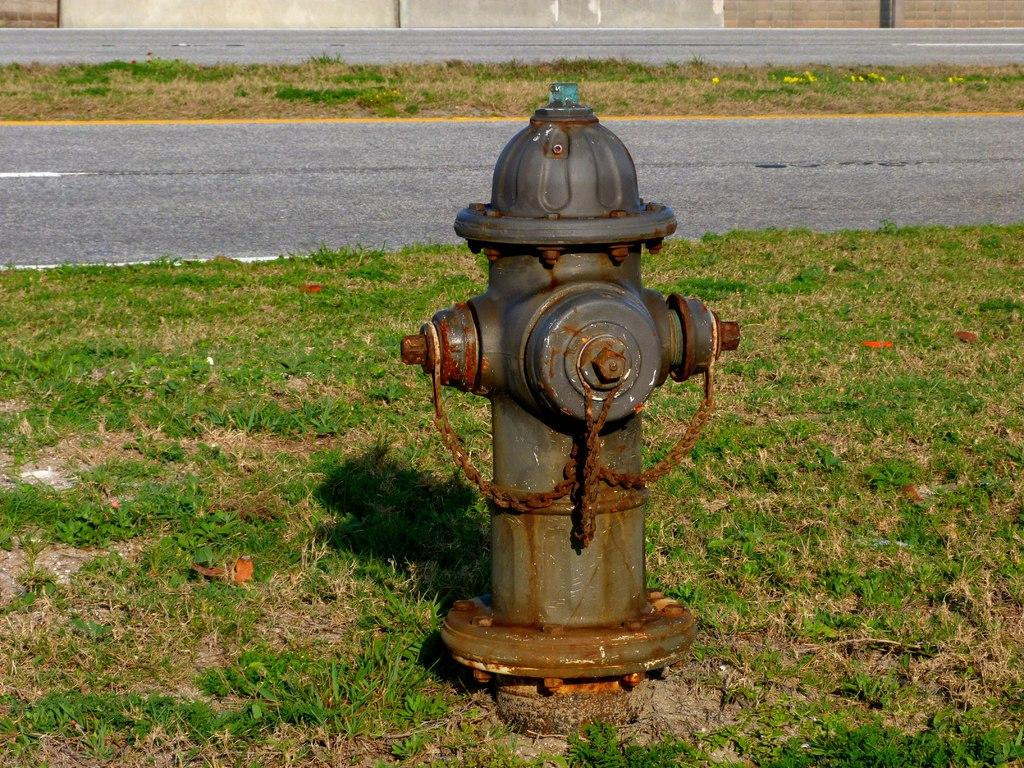What object is the main subject of the image? There is a fire hydrant in the image. What type of vegetation is present around the fire hydrant? Grass is present around the fire hydrant. What can be seen in the background of the image? There is grass, a road, and a wall visible in the background of the image. What shape is the jail in the image? There is no jail present in the image. What effect does the fire hydrant have on the grass in the image? The fire hydrant does not have any effect on the grass in the image; it is simply a stationary object surrounded by grass. 